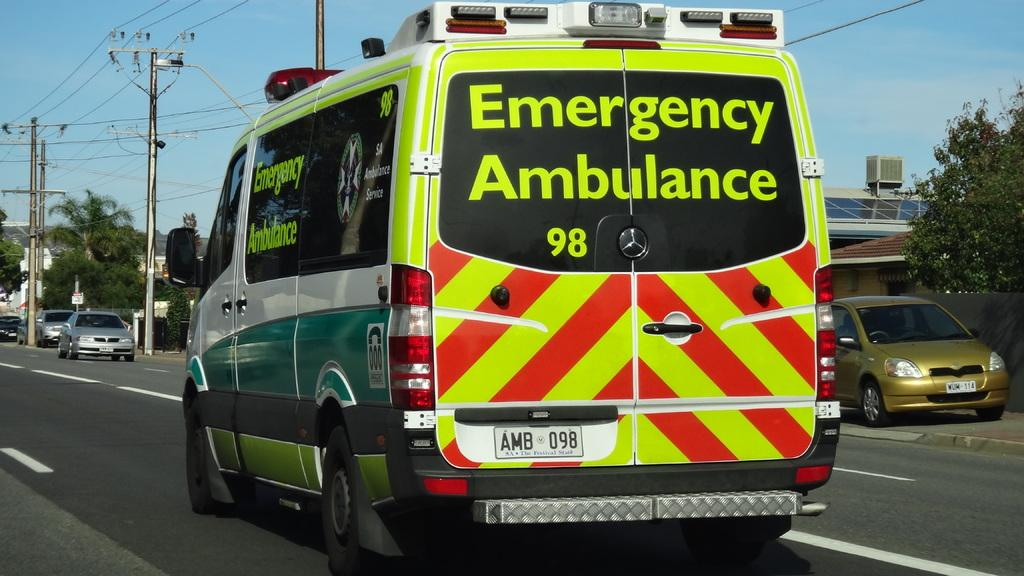<image>
Render a clear and concise summary of the photo. The vehicle shown travelling down the road is an Emergency Ambulance. 